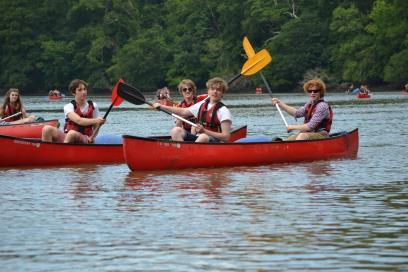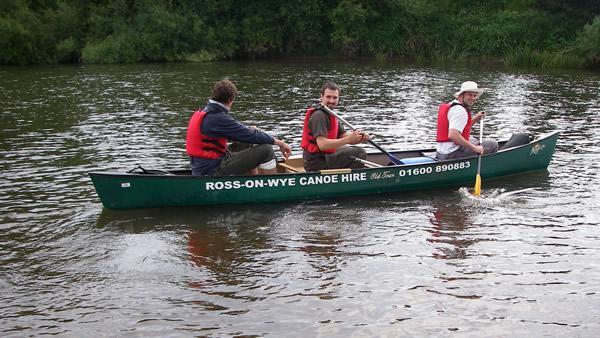The first image is the image on the left, the second image is the image on the right. For the images displayed, is the sentence "Right image shows a canoe holding three people who all wear red life vests." factually correct? Answer yes or no. Yes. 